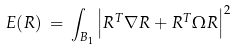<formula> <loc_0><loc_0><loc_500><loc_500>E ( R ) \, = \, \int _ { B _ { 1 } } \left | R ^ { T } \nabla R + R ^ { T } \Omega R \right | ^ { 2 }</formula> 